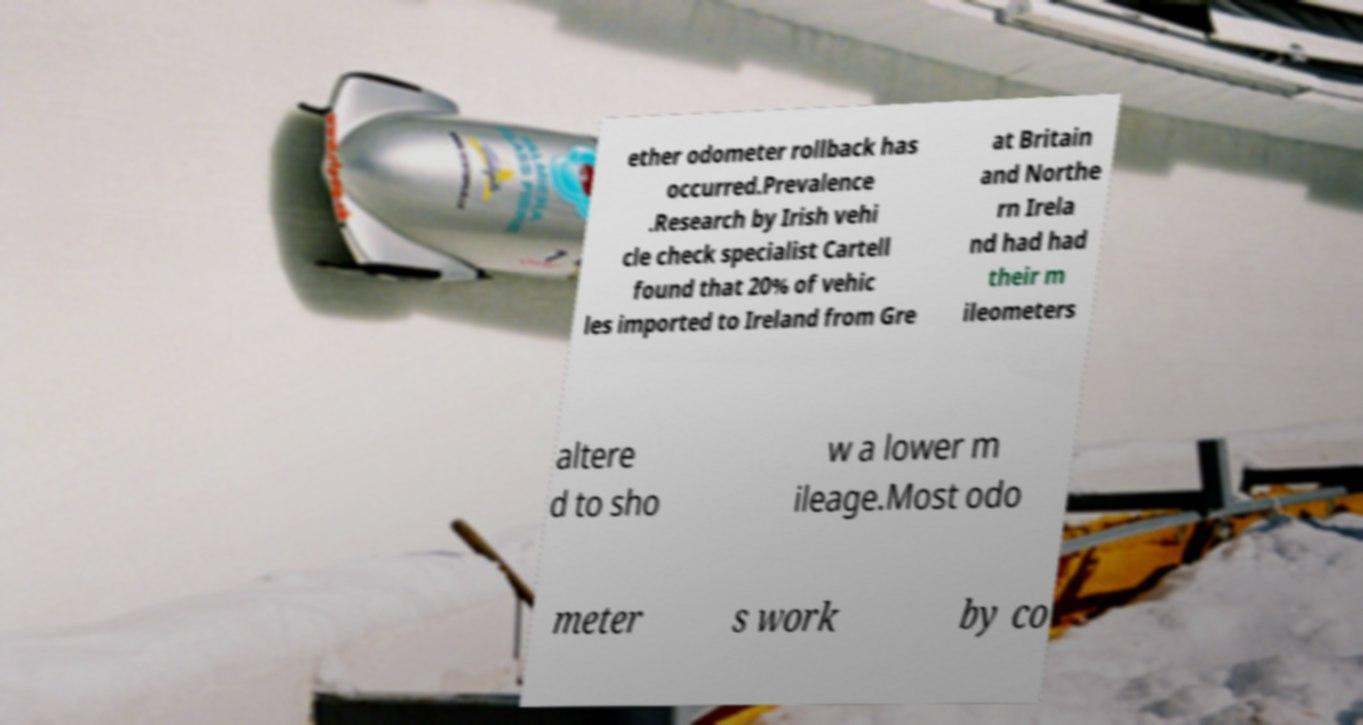For documentation purposes, I need the text within this image transcribed. Could you provide that? ether odometer rollback has occurred.Prevalence .Research by Irish vehi cle check specialist Cartell found that 20% of vehic les imported to Ireland from Gre at Britain and Northe rn Irela nd had had their m ileometers altere d to sho w a lower m ileage.Most odo meter s work by co 